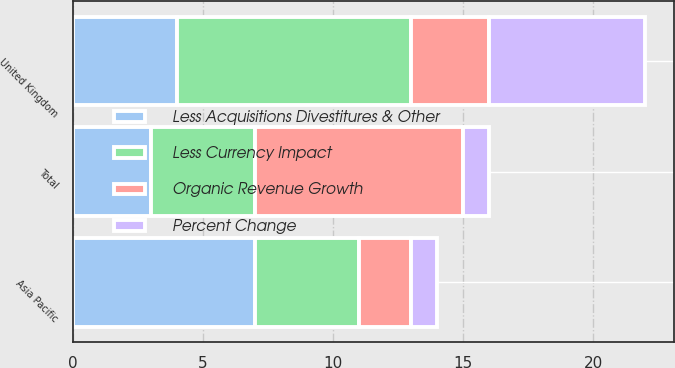Convert chart to OTSL. <chart><loc_0><loc_0><loc_500><loc_500><stacked_bar_chart><ecel><fcel>United Kingdom<fcel>Asia Pacific<fcel>Total<nl><fcel>Less Acquisitions Divestitures & Other<fcel>4<fcel>7<fcel>3<nl><fcel>Less Currency Impact<fcel>9<fcel>4<fcel>4<nl><fcel>Organic Revenue Growth<fcel>3<fcel>2<fcel>8<nl><fcel>Percent Change<fcel>6<fcel>1<fcel>1<nl></chart> 